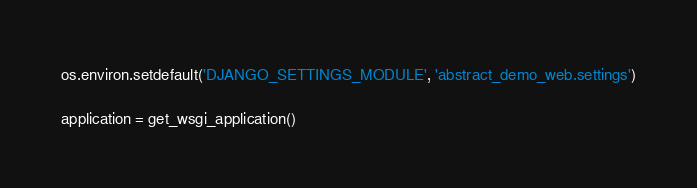<code> <loc_0><loc_0><loc_500><loc_500><_Python_>
os.environ.setdefault('DJANGO_SETTINGS_MODULE', 'abstract_demo_web.settings')

application = get_wsgi_application()
</code> 